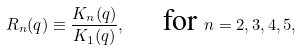<formula> <loc_0><loc_0><loc_500><loc_500>R _ { n } ( q ) \equiv \frac { K _ { n } ( q ) } { K _ { 1 } ( q ) } , \quad \text { for } n = 2 , 3 , 4 , 5 ,</formula> 